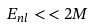<formula> <loc_0><loc_0><loc_500><loc_500>E _ { n l } < \, < 2 M</formula> 